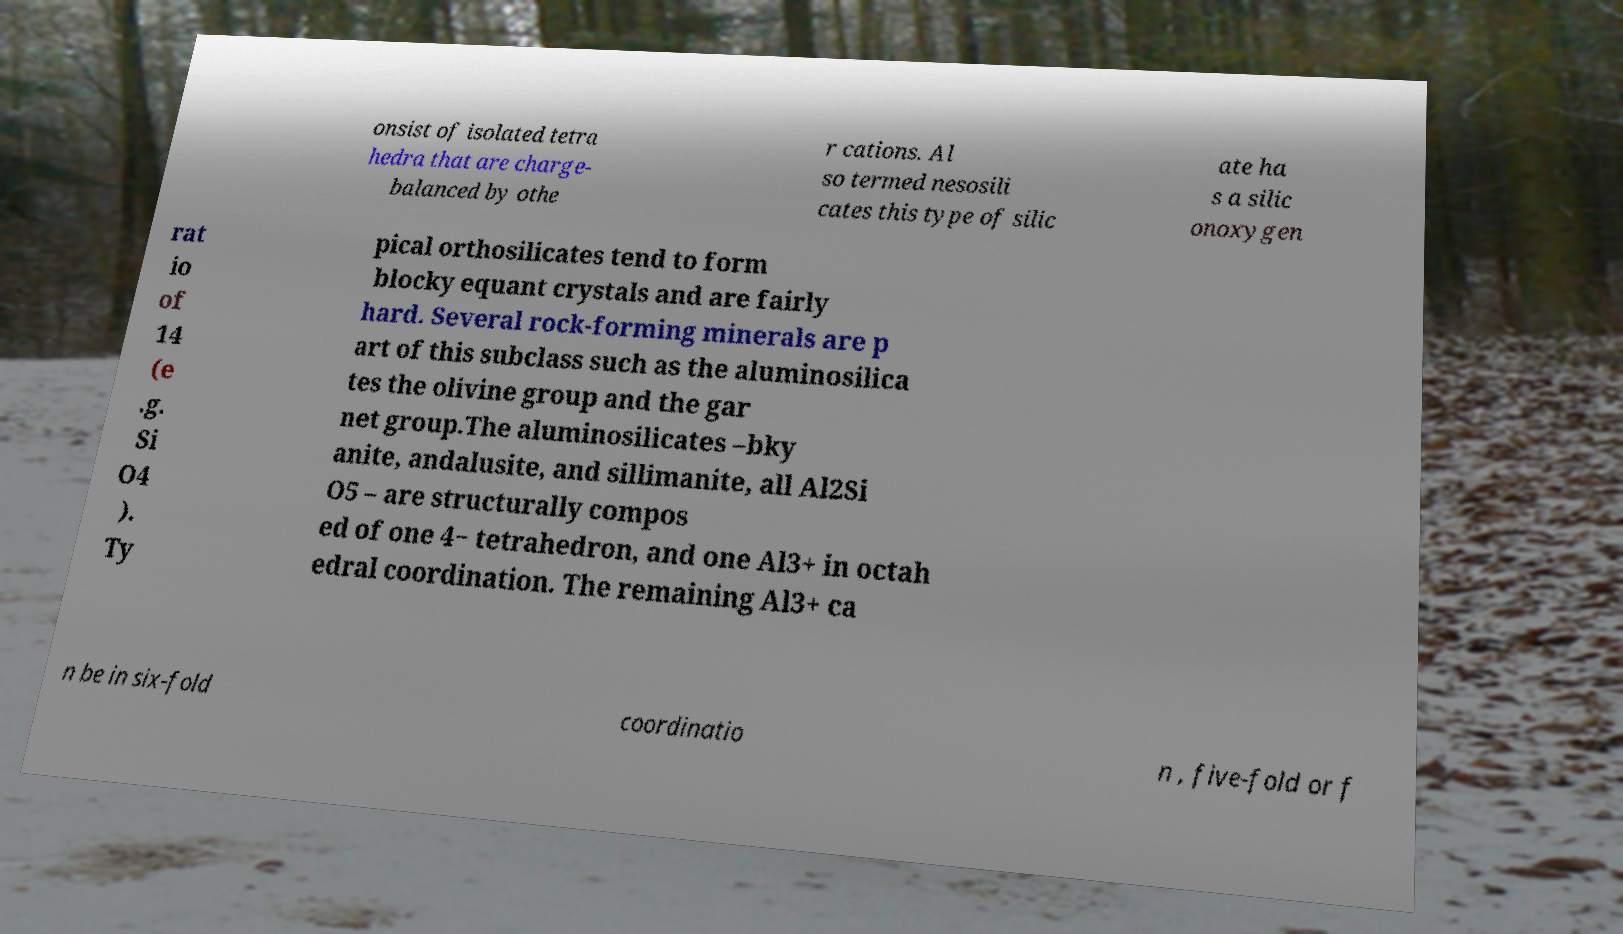Please read and relay the text visible in this image. What does it say? onsist of isolated tetra hedra that are charge- balanced by othe r cations. Al so termed nesosili cates this type of silic ate ha s a silic onoxygen rat io of 14 (e .g. Si O4 ). Ty pical orthosilicates tend to form blocky equant crystals and are fairly hard. Several rock-forming minerals are p art of this subclass such as the aluminosilica tes the olivine group and the gar net group.The aluminosilicates –bky anite, andalusite, and sillimanite, all Al2Si O5 – are structurally compos ed of one 4− tetrahedron, and one Al3+ in octah edral coordination. The remaining Al3+ ca n be in six-fold coordinatio n , five-fold or f 